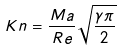<formula> <loc_0><loc_0><loc_500><loc_500>K n = \frac { M a } { R e } \sqrt { \frac { \gamma \pi } { 2 } }</formula> 